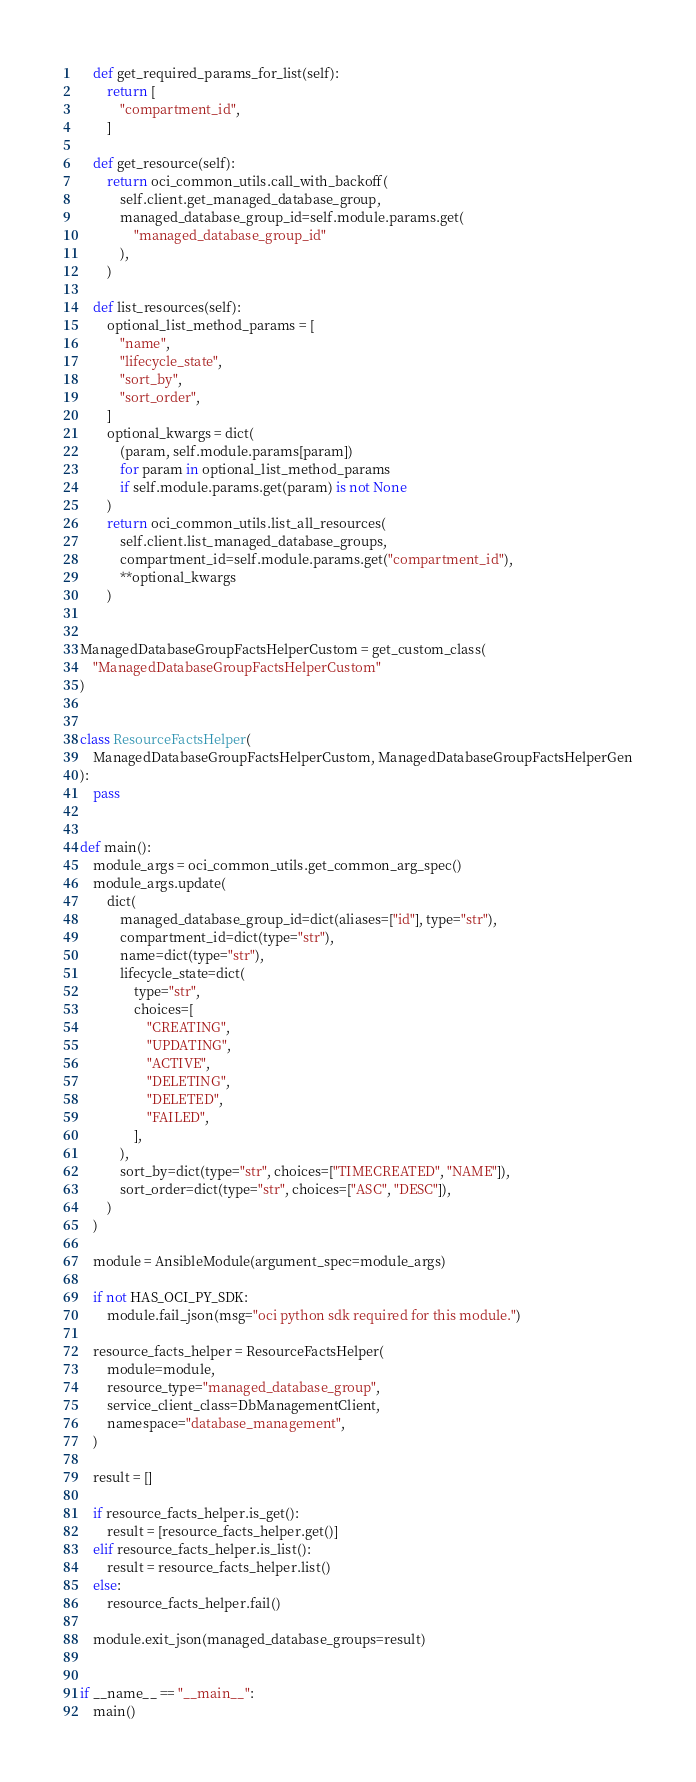Convert code to text. <code><loc_0><loc_0><loc_500><loc_500><_Python_>
    def get_required_params_for_list(self):
        return [
            "compartment_id",
        ]

    def get_resource(self):
        return oci_common_utils.call_with_backoff(
            self.client.get_managed_database_group,
            managed_database_group_id=self.module.params.get(
                "managed_database_group_id"
            ),
        )

    def list_resources(self):
        optional_list_method_params = [
            "name",
            "lifecycle_state",
            "sort_by",
            "sort_order",
        ]
        optional_kwargs = dict(
            (param, self.module.params[param])
            for param in optional_list_method_params
            if self.module.params.get(param) is not None
        )
        return oci_common_utils.list_all_resources(
            self.client.list_managed_database_groups,
            compartment_id=self.module.params.get("compartment_id"),
            **optional_kwargs
        )


ManagedDatabaseGroupFactsHelperCustom = get_custom_class(
    "ManagedDatabaseGroupFactsHelperCustom"
)


class ResourceFactsHelper(
    ManagedDatabaseGroupFactsHelperCustom, ManagedDatabaseGroupFactsHelperGen
):
    pass


def main():
    module_args = oci_common_utils.get_common_arg_spec()
    module_args.update(
        dict(
            managed_database_group_id=dict(aliases=["id"], type="str"),
            compartment_id=dict(type="str"),
            name=dict(type="str"),
            lifecycle_state=dict(
                type="str",
                choices=[
                    "CREATING",
                    "UPDATING",
                    "ACTIVE",
                    "DELETING",
                    "DELETED",
                    "FAILED",
                ],
            ),
            sort_by=dict(type="str", choices=["TIMECREATED", "NAME"]),
            sort_order=dict(type="str", choices=["ASC", "DESC"]),
        )
    )

    module = AnsibleModule(argument_spec=module_args)

    if not HAS_OCI_PY_SDK:
        module.fail_json(msg="oci python sdk required for this module.")

    resource_facts_helper = ResourceFactsHelper(
        module=module,
        resource_type="managed_database_group",
        service_client_class=DbManagementClient,
        namespace="database_management",
    )

    result = []

    if resource_facts_helper.is_get():
        result = [resource_facts_helper.get()]
    elif resource_facts_helper.is_list():
        result = resource_facts_helper.list()
    else:
        resource_facts_helper.fail()

    module.exit_json(managed_database_groups=result)


if __name__ == "__main__":
    main()
</code> 